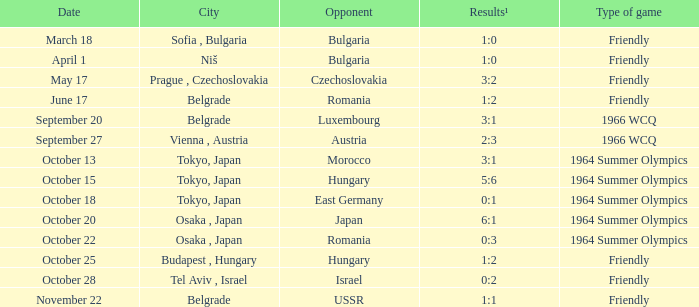What day were the results 3:2? May 17. 